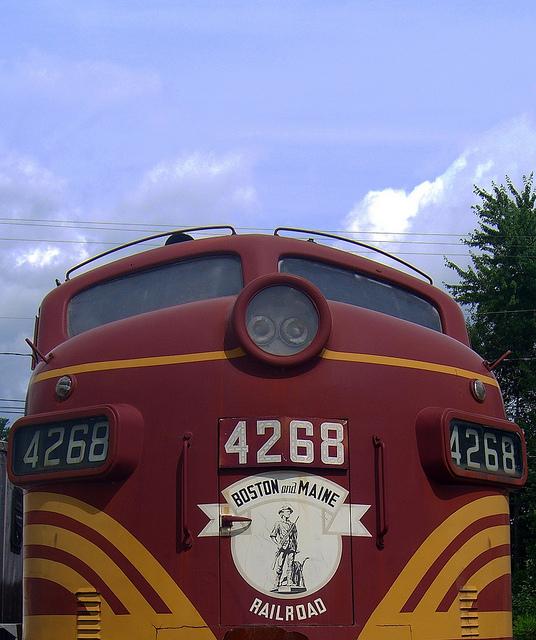Does this train share a color scheme with the Cleveland Cavaliers' uniforms?
Write a very short answer. Yes. Is it morning?
Be succinct. Yes. What numbers are on the front of this train?
Be succinct. 4268. 